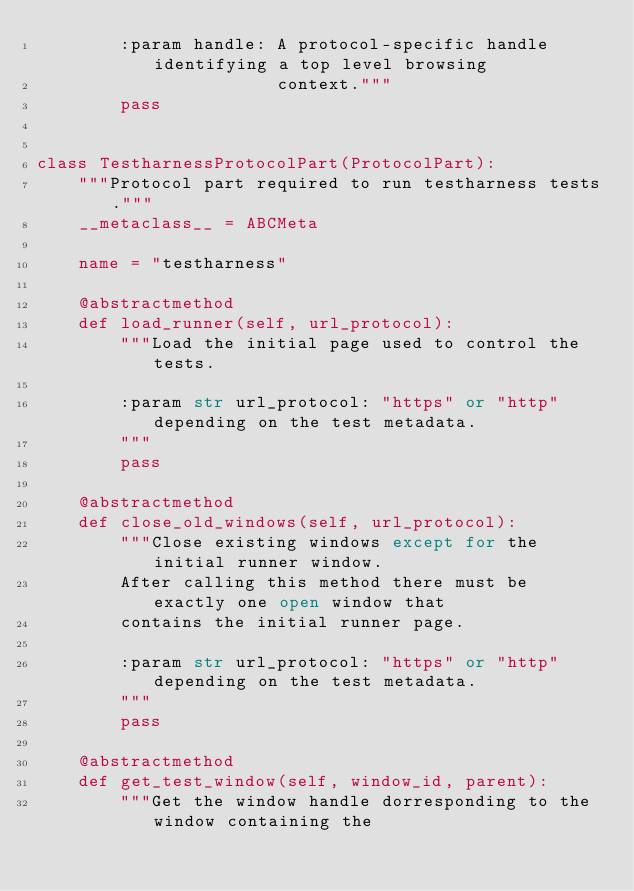<code> <loc_0><loc_0><loc_500><loc_500><_Python_>        :param handle: A protocol-specific handle identifying a top level browsing
                       context."""
        pass


class TestharnessProtocolPart(ProtocolPart):
    """Protocol part required to run testharness tests."""
    __metaclass__ = ABCMeta

    name = "testharness"

    @abstractmethod
    def load_runner(self, url_protocol):
        """Load the initial page used to control the tests.

        :param str url_protocol: "https" or "http" depending on the test metadata.
        """
        pass

    @abstractmethod
    def close_old_windows(self, url_protocol):
        """Close existing windows except for the initial runner window.
        After calling this method there must be exactly one open window that
        contains the initial runner page.

        :param str url_protocol: "https" or "http" depending on the test metadata.
        """
        pass

    @abstractmethod
    def get_test_window(self, window_id, parent):
        """Get the window handle dorresponding to the window containing the</code> 